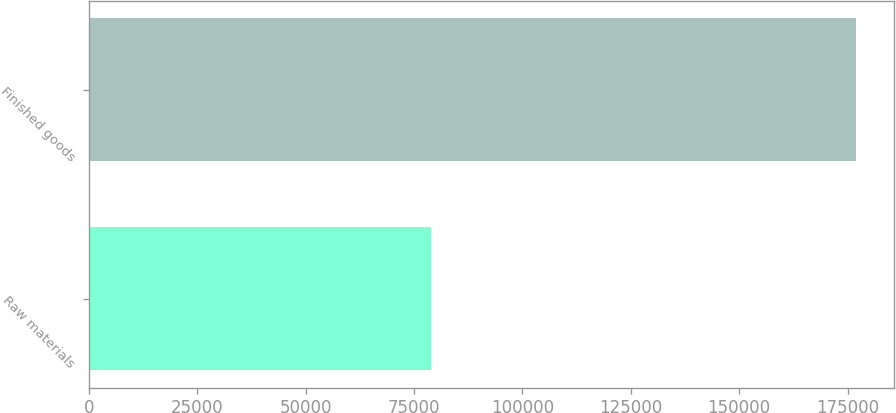Convert chart. <chart><loc_0><loc_0><loc_500><loc_500><bar_chart><fcel>Raw materials<fcel>Finished goods<nl><fcel>78834<fcel>176911<nl></chart> 